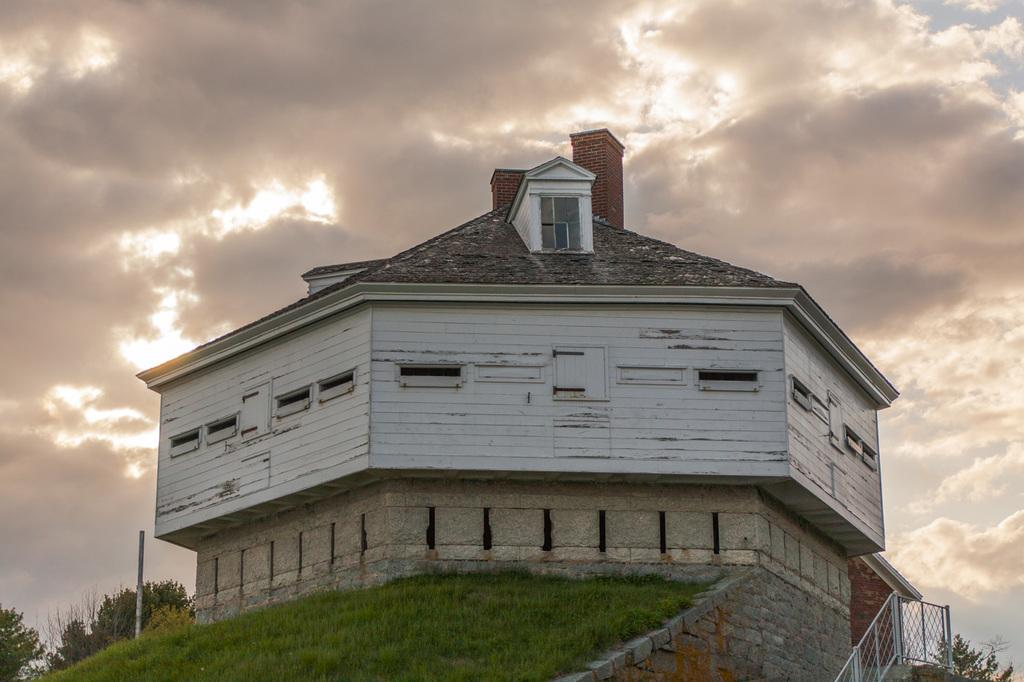What type of structure is present in the image? There is a house in the image. What features can be observed on the house? The house has windows and a roof. Can you describe any architectural elements in the image? There is a staircase with a railing in the image. What type of vegetation is visible in the image? There is grass visible in the image, as well as trees. What is the condition of the sky in the image? The sky is visible in the image and appears cloudy. How many jellyfish can be seen swimming in the grass in the image? There are no jellyfish present in the image; the vegetation visible is grass. What type of yarn is being used to create the scarecrow in the image? There is no scarecrow present in the image, so it is not possible to determine what type of yarn might be used. 